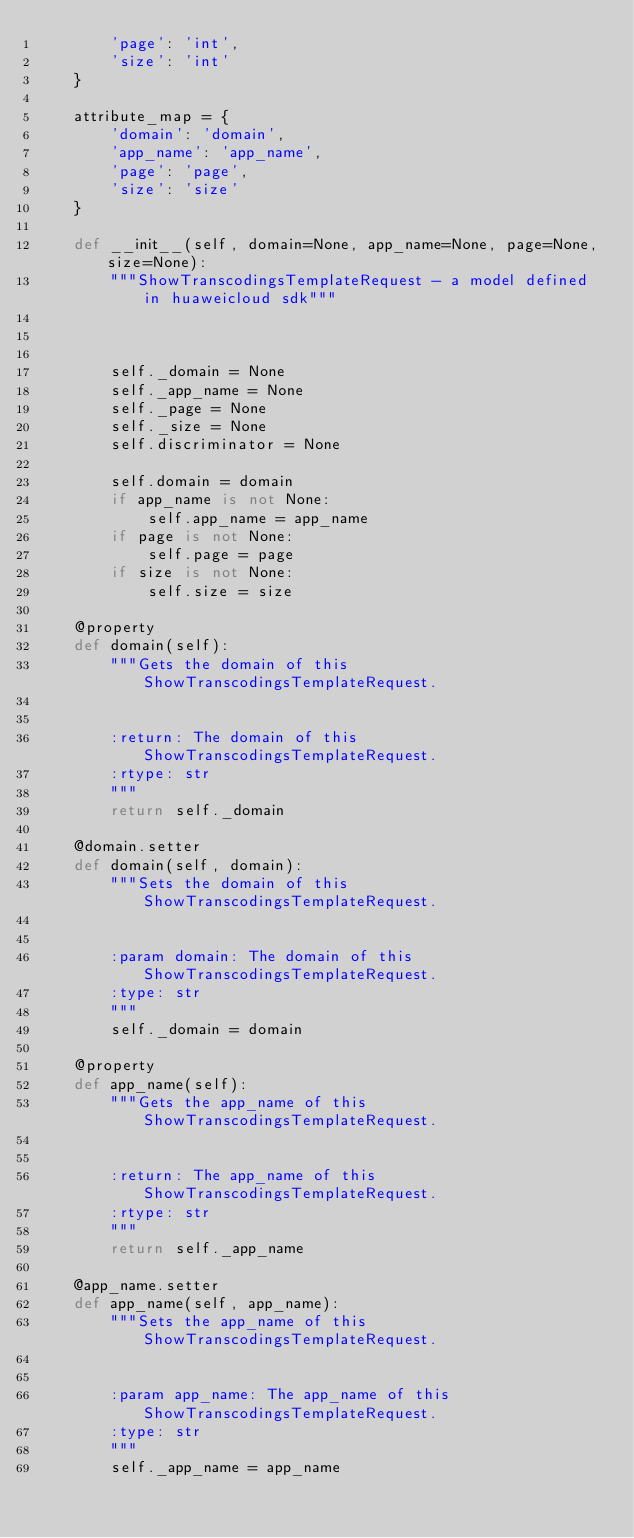<code> <loc_0><loc_0><loc_500><loc_500><_Python_>        'page': 'int',
        'size': 'int'
    }

    attribute_map = {
        'domain': 'domain',
        'app_name': 'app_name',
        'page': 'page',
        'size': 'size'
    }

    def __init__(self, domain=None, app_name=None, page=None, size=None):
        """ShowTranscodingsTemplateRequest - a model defined in huaweicloud sdk"""
        
        

        self._domain = None
        self._app_name = None
        self._page = None
        self._size = None
        self.discriminator = None

        self.domain = domain
        if app_name is not None:
            self.app_name = app_name
        if page is not None:
            self.page = page
        if size is not None:
            self.size = size

    @property
    def domain(self):
        """Gets the domain of this ShowTranscodingsTemplateRequest.


        :return: The domain of this ShowTranscodingsTemplateRequest.
        :rtype: str
        """
        return self._domain

    @domain.setter
    def domain(self, domain):
        """Sets the domain of this ShowTranscodingsTemplateRequest.


        :param domain: The domain of this ShowTranscodingsTemplateRequest.
        :type: str
        """
        self._domain = domain

    @property
    def app_name(self):
        """Gets the app_name of this ShowTranscodingsTemplateRequest.


        :return: The app_name of this ShowTranscodingsTemplateRequest.
        :rtype: str
        """
        return self._app_name

    @app_name.setter
    def app_name(self, app_name):
        """Sets the app_name of this ShowTranscodingsTemplateRequest.


        :param app_name: The app_name of this ShowTranscodingsTemplateRequest.
        :type: str
        """
        self._app_name = app_name
</code> 